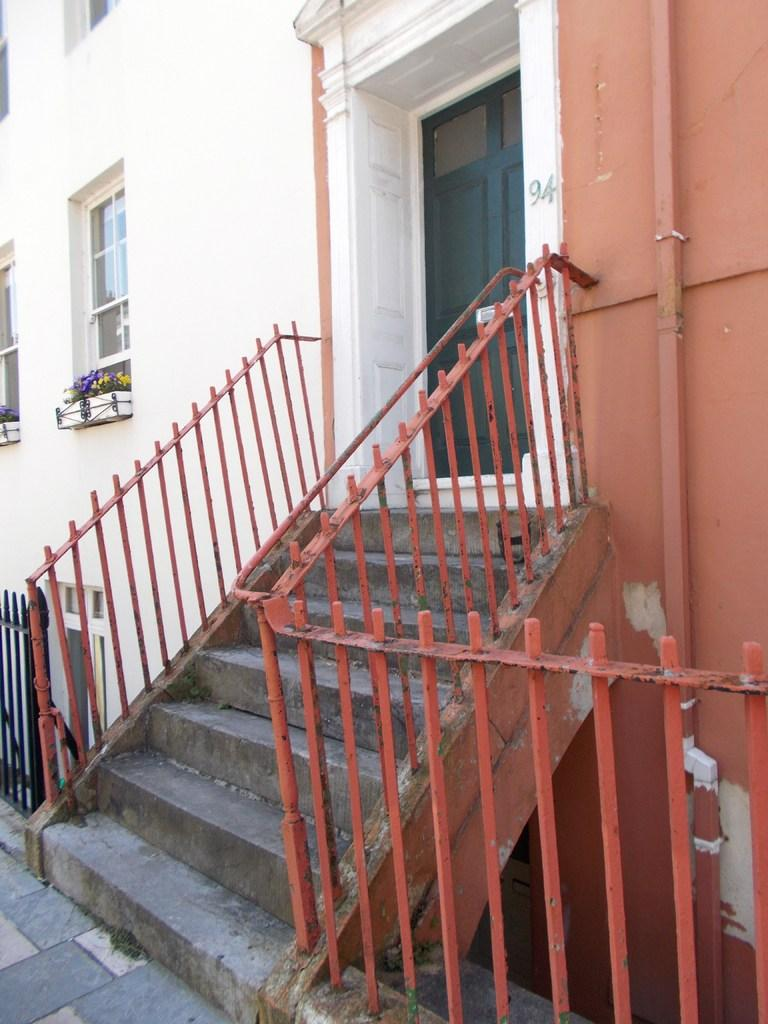What type of architectural feature can be seen in the image? There are steps in the image. What safety feature is present alongside the steps? There are railings in the image. What can be seen through the windows in the image? There is a building in the image that can be seen through the windows. How can someone enter or exit the building in the image? There is a door in the image that can be used for entering or exiting. What type of vegetation is present in the image? There are plants and flowers in the image. Can you touch the skate in the image? There is no skate present in the image. What type of cellar can be seen in the image? There is no cellar present in the image. 